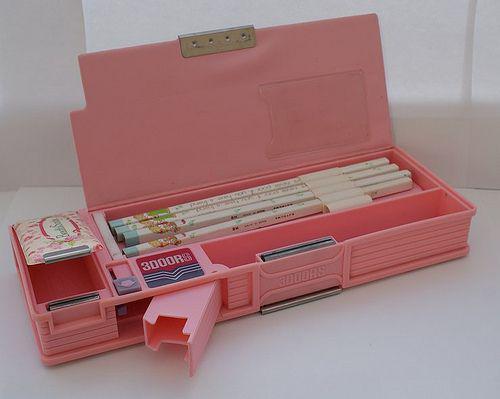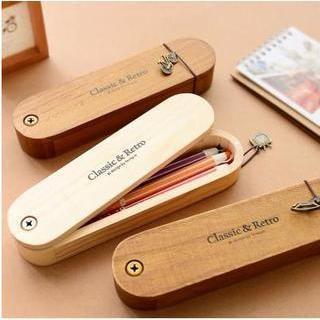The first image is the image on the left, the second image is the image on the right. Considering the images on both sides, is "One image features a single pastel-colored plastic-look case with a side part that can extend outward." valid? Answer yes or no. Yes. The first image is the image on the left, the second image is the image on the right. For the images shown, is this caption "The left image contain a single pencil case that is predominantly pink." true? Answer yes or no. Yes. The first image is the image on the left, the second image is the image on the right. Assess this claim about the two images: "Multiple writing implements are shown with pencil cases in each image.". Correct or not? Answer yes or no. Yes. The first image is the image on the left, the second image is the image on the right. Assess this claim about the two images: "There is a predominantly pink pencel case on top of a white table in one of the images.". Correct or not? Answer yes or no. Yes. 